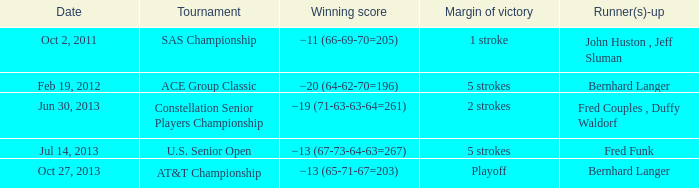Which Date has a Runner(s)-up of fred funk? Jul 14, 2013. 